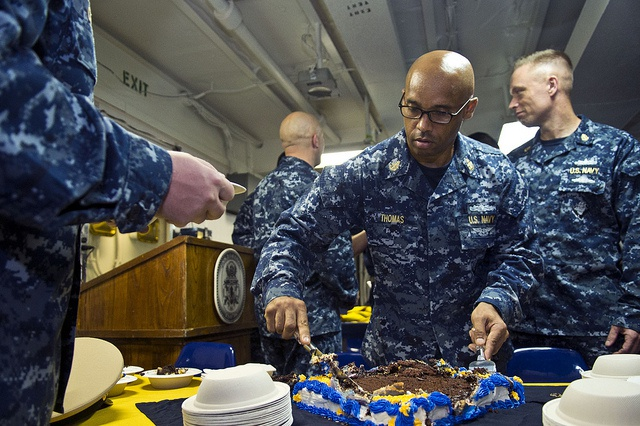Describe the objects in this image and their specific colors. I can see people in black, navy, gray, and darkblue tones, people in black, navy, gray, and darkblue tones, people in black, navy, darkblue, and gray tones, cake in black, gray, navy, and darkgray tones, and people in black, gray, navy, and tan tones in this image. 